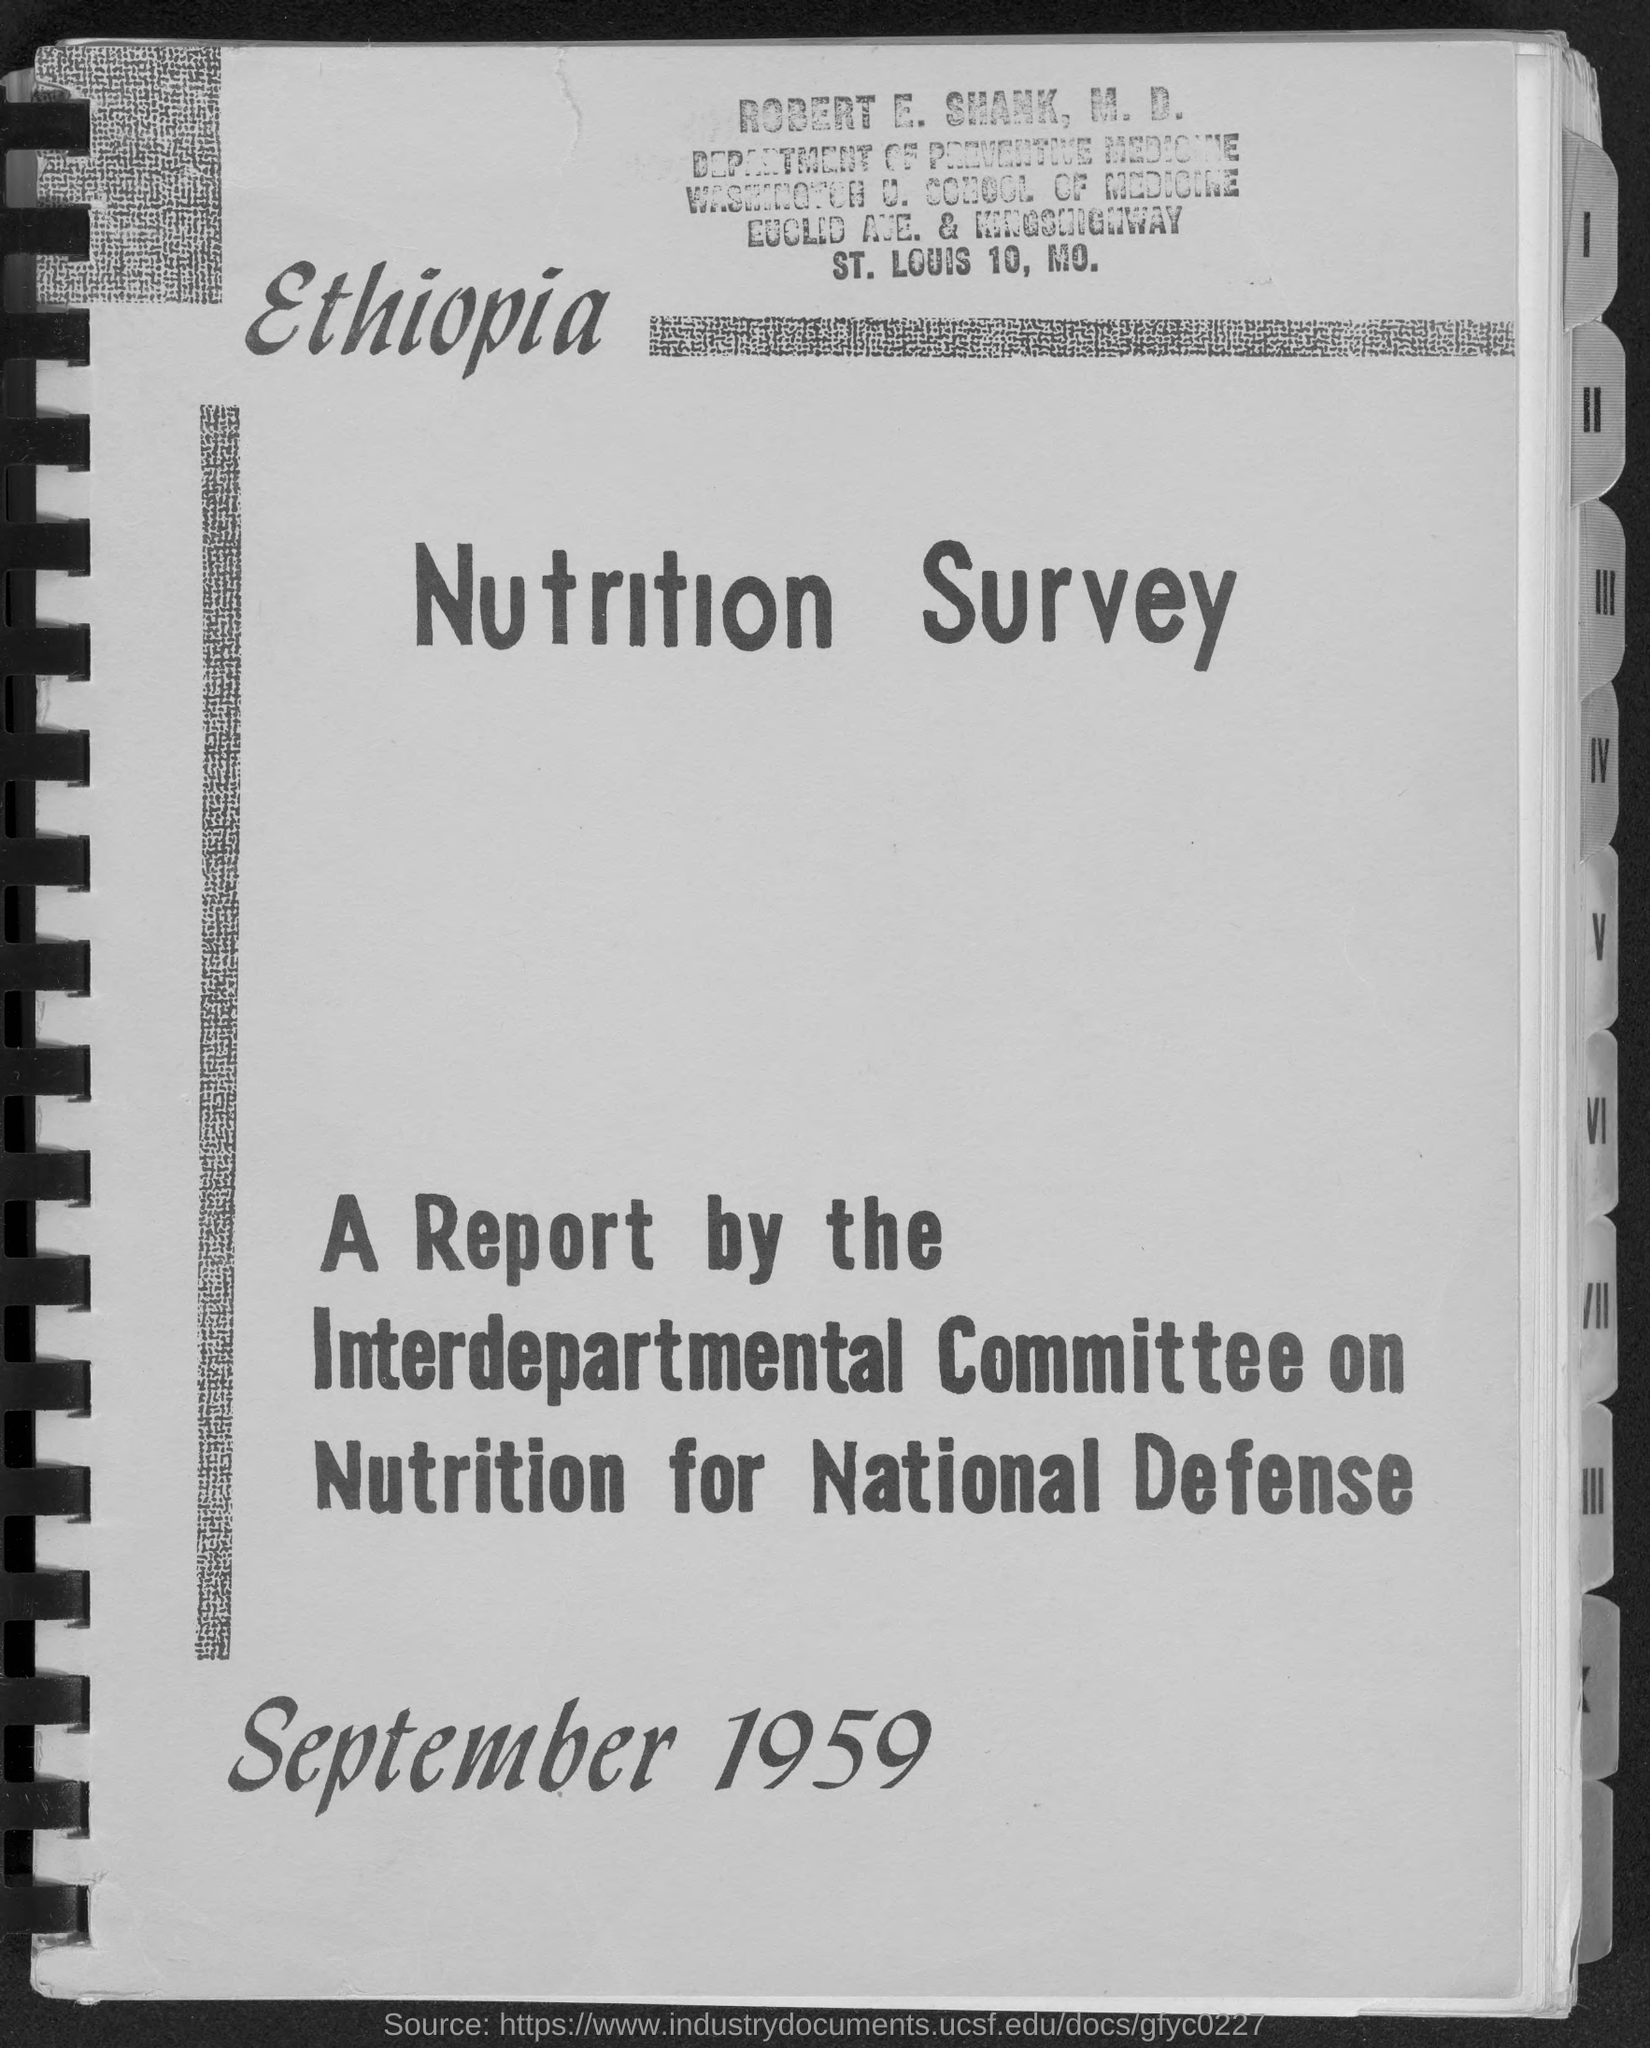To which department does Robert E. Shank, M.D. belong ?
Keep it short and to the point. Department of preventive medicine. What is the month and year at bottom of the page ?
Make the answer very short. September 1959. 